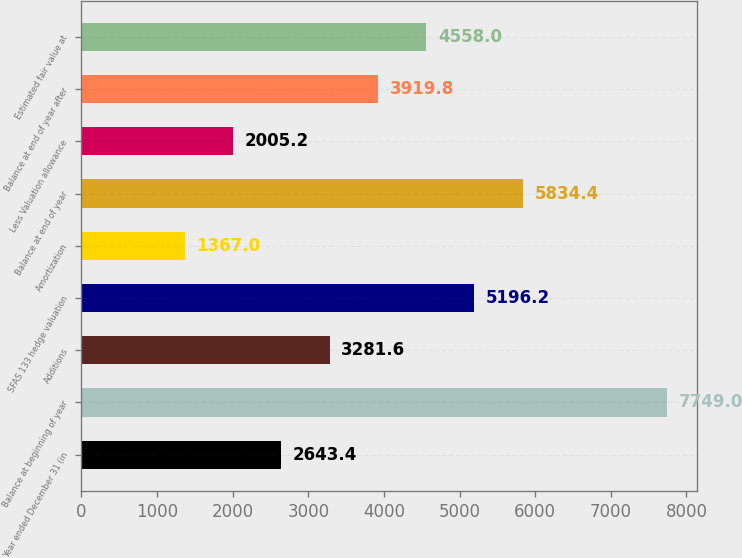Convert chart to OTSL. <chart><loc_0><loc_0><loc_500><loc_500><bar_chart><fcel>Year ended December 31 (in<fcel>Balance at beginning of year<fcel>Additions<fcel>SFAS 133 hedge valuation<fcel>Amortization<fcel>Balance at end of year<fcel>Less Valuation allowance<fcel>Balance at end of year after<fcel>Estimated fair value at<nl><fcel>2643.4<fcel>7749<fcel>3281.6<fcel>5196.2<fcel>1367<fcel>5834.4<fcel>2005.2<fcel>3919.8<fcel>4558<nl></chart> 